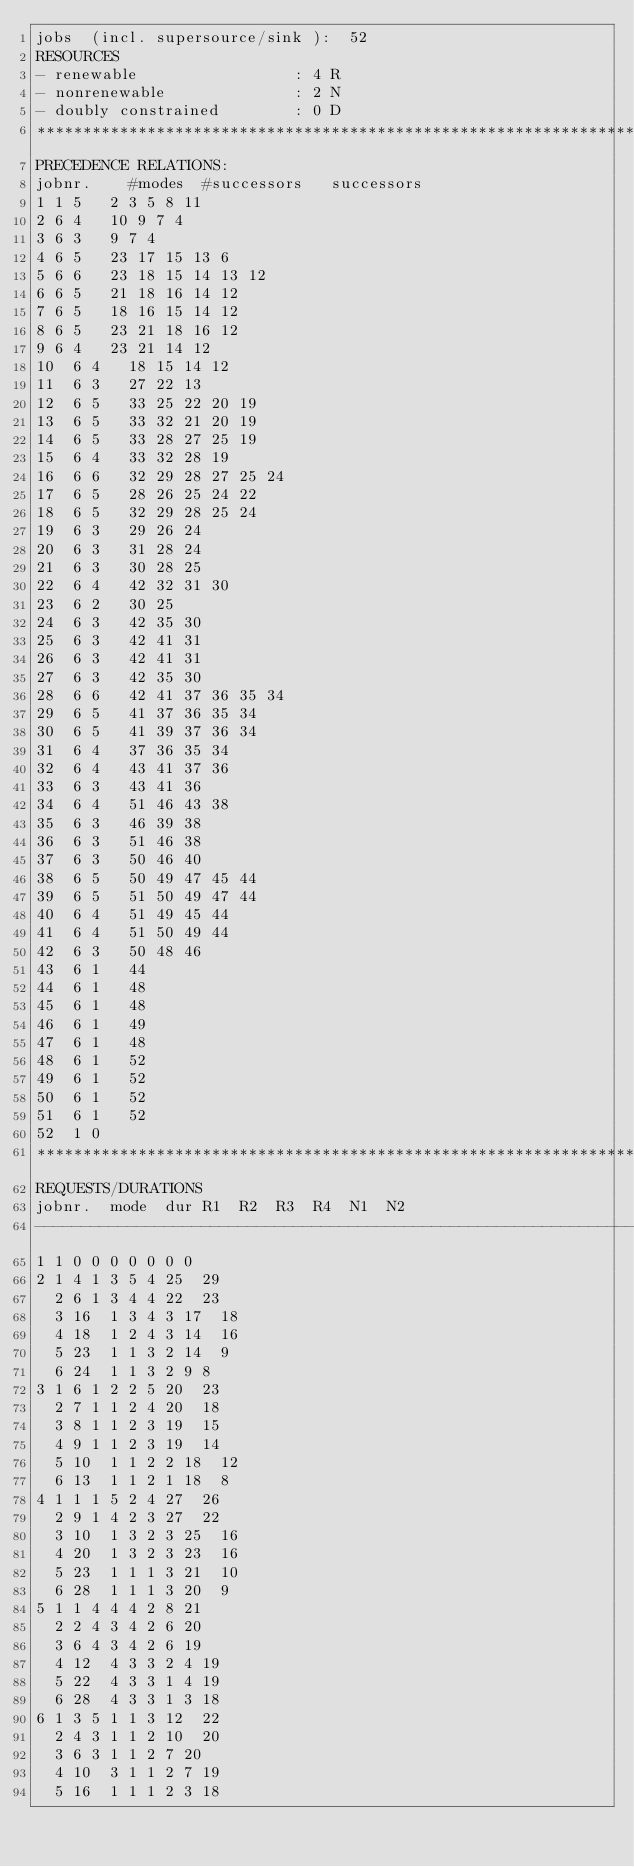Convert code to text. <code><loc_0><loc_0><loc_500><loc_500><_ObjectiveC_>jobs  (incl. supersource/sink ):	52
RESOURCES
- renewable                 : 4 R
- nonrenewable              : 2 N
- doubly constrained        : 0 D
************************************************************************
PRECEDENCE RELATIONS:
jobnr.    #modes  #successors   successors
1	1	5		2 3 5 8 11 
2	6	4		10 9 7 4 
3	6	3		9 7 4 
4	6	5		23 17 15 13 6 
5	6	6		23 18 15 14 13 12 
6	6	5		21 18 16 14 12 
7	6	5		18 16 15 14 12 
8	6	5		23 21 18 16 12 
9	6	4		23 21 14 12 
10	6	4		18 15 14 12 
11	6	3		27 22 13 
12	6	5		33 25 22 20 19 
13	6	5		33 32 21 20 19 
14	6	5		33 28 27 25 19 
15	6	4		33 32 28 19 
16	6	6		32 29 28 27 25 24 
17	6	5		28 26 25 24 22 
18	6	5		32 29 28 25 24 
19	6	3		29 26 24 
20	6	3		31 28 24 
21	6	3		30 28 25 
22	6	4		42 32 31 30 
23	6	2		30 25 
24	6	3		42 35 30 
25	6	3		42 41 31 
26	6	3		42 41 31 
27	6	3		42 35 30 
28	6	6		42 41 37 36 35 34 
29	6	5		41 37 36 35 34 
30	6	5		41 39 37 36 34 
31	6	4		37 36 35 34 
32	6	4		43 41 37 36 
33	6	3		43 41 36 
34	6	4		51 46 43 38 
35	6	3		46 39 38 
36	6	3		51 46 38 
37	6	3		50 46 40 
38	6	5		50 49 47 45 44 
39	6	5		51 50 49 47 44 
40	6	4		51 49 45 44 
41	6	4		51 50 49 44 
42	6	3		50 48 46 
43	6	1		44 
44	6	1		48 
45	6	1		48 
46	6	1		49 
47	6	1		48 
48	6	1		52 
49	6	1		52 
50	6	1		52 
51	6	1		52 
52	1	0		
************************************************************************
REQUESTS/DURATIONS
jobnr.	mode	dur	R1	R2	R3	R4	N1	N2	
------------------------------------------------------------------------
1	1	0	0	0	0	0	0	0	
2	1	4	1	3	5	4	25	29	
	2	6	1	3	4	4	22	23	
	3	16	1	3	4	3	17	18	
	4	18	1	2	4	3	14	16	
	5	23	1	1	3	2	14	9	
	6	24	1	1	3	2	9	8	
3	1	6	1	2	2	5	20	23	
	2	7	1	1	2	4	20	18	
	3	8	1	1	2	3	19	15	
	4	9	1	1	2	3	19	14	
	5	10	1	1	2	2	18	12	
	6	13	1	1	2	1	18	8	
4	1	1	1	5	2	4	27	26	
	2	9	1	4	2	3	27	22	
	3	10	1	3	2	3	25	16	
	4	20	1	3	2	3	23	16	
	5	23	1	1	1	3	21	10	
	6	28	1	1	1	3	20	9	
5	1	1	4	4	4	2	8	21	
	2	2	4	3	4	2	6	20	
	3	6	4	3	4	2	6	19	
	4	12	4	3	3	2	4	19	
	5	22	4	3	3	1	4	19	
	6	28	4	3	3	1	3	18	
6	1	3	5	1	1	3	12	22	
	2	4	3	1	1	2	10	20	
	3	6	3	1	1	2	7	20	
	4	10	3	1	1	2	7	19	
	5	16	1	1	1	2	3	18	</code> 